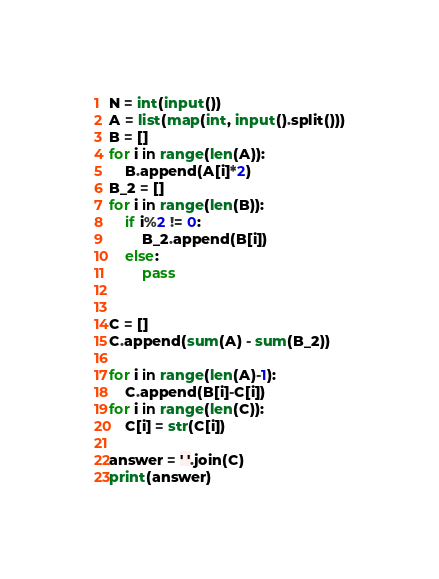<code> <loc_0><loc_0><loc_500><loc_500><_Python_>N = int(input())
A = list(map(int, input().split()))
B = []
for i in range(len(A)):
    B.append(A[i]*2)
B_2 = []
for i in range(len(B)):
    if i%2 != 0:
        B_2.append(B[i])
    else:
        pass


C = []
C.append(sum(A) - sum(B_2)) 

for i in range(len(A)-1):
    C.append(B[i]-C[i])
for i in range(len(C)):
    C[i] = str(C[i])

answer = ' '.join(C)
print(answer)</code> 